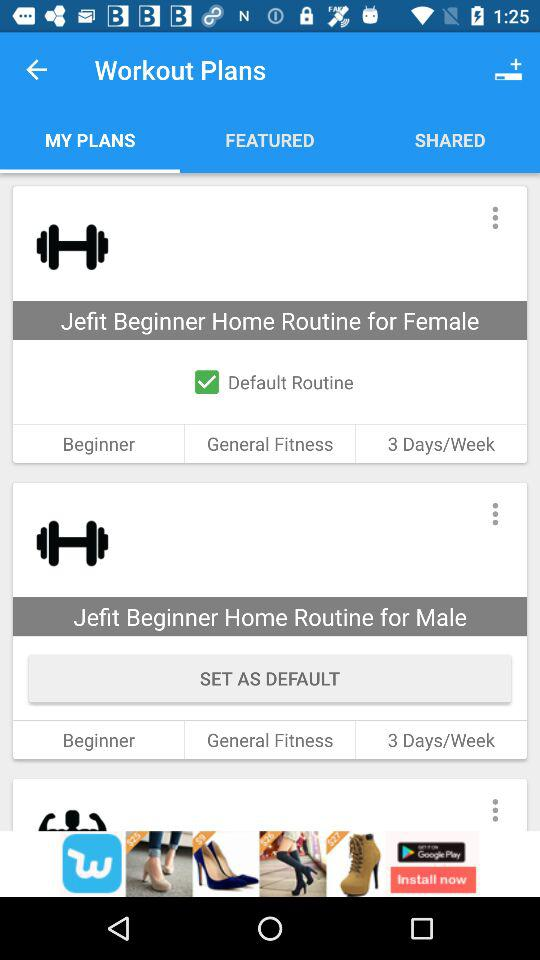Which tab is selected? The selected tab is "MY PLANS". 